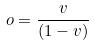Convert formula to latex. <formula><loc_0><loc_0><loc_500><loc_500>o = \frac { v } { ( 1 - v ) }</formula> 